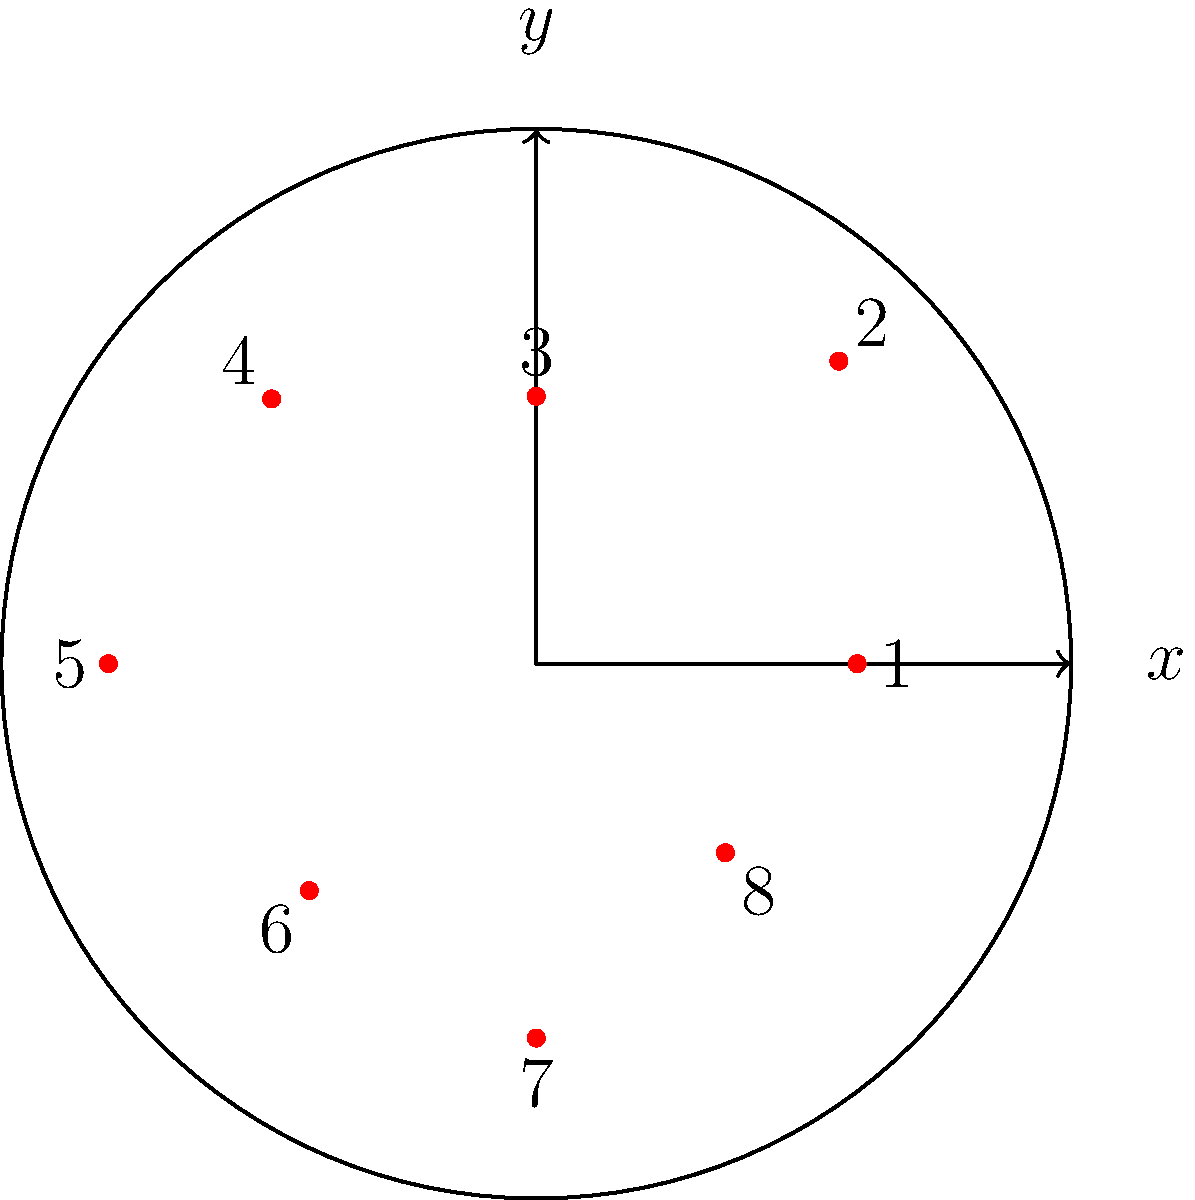In a circular city with a radius of 5 miles, 8 police stations are strategically placed as shown in the diagram. Each station's location is given in polar coordinates $(r,\theta)$, where $r$ is the distance from the city center (in miles) and $\theta$ is the angle from the positive x-axis (in degrees). Which police station is located closest to the city center, and what is its distance from the center? To solve this problem, we need to compare the radial distances ($r$) of all police stations:

1. Station 1: $r = 3$ miles, $\theta = 0°$
2. Station 2: $r = 4$ miles, $\theta = 45°$
3. Station 3: $r = 2.5$ miles, $\theta = 90°$
4. Station 4: $r = 3.5$ miles, $\theta = 135°$
5. Station 5: $r = 4$ miles, $\theta = 180°$
6. Station 6: $r = 3$ miles, $\theta = 225°$
7. Station 7: $r = 3.5$ miles, $\theta = 270°$
8. Station 8: $r = 2.5$ miles, $\theta = 315°$

The station with the smallest $r$ value is closest to the city center. We can see that stations 3 and 8 both have the smallest $r$ value of 2.5 miles.

Since the question asks for a single station, we can choose either Station 3 or Station 8 as the answer. Let's select Station 3 for our final answer.
Answer: Station 3, 2.5 miles 